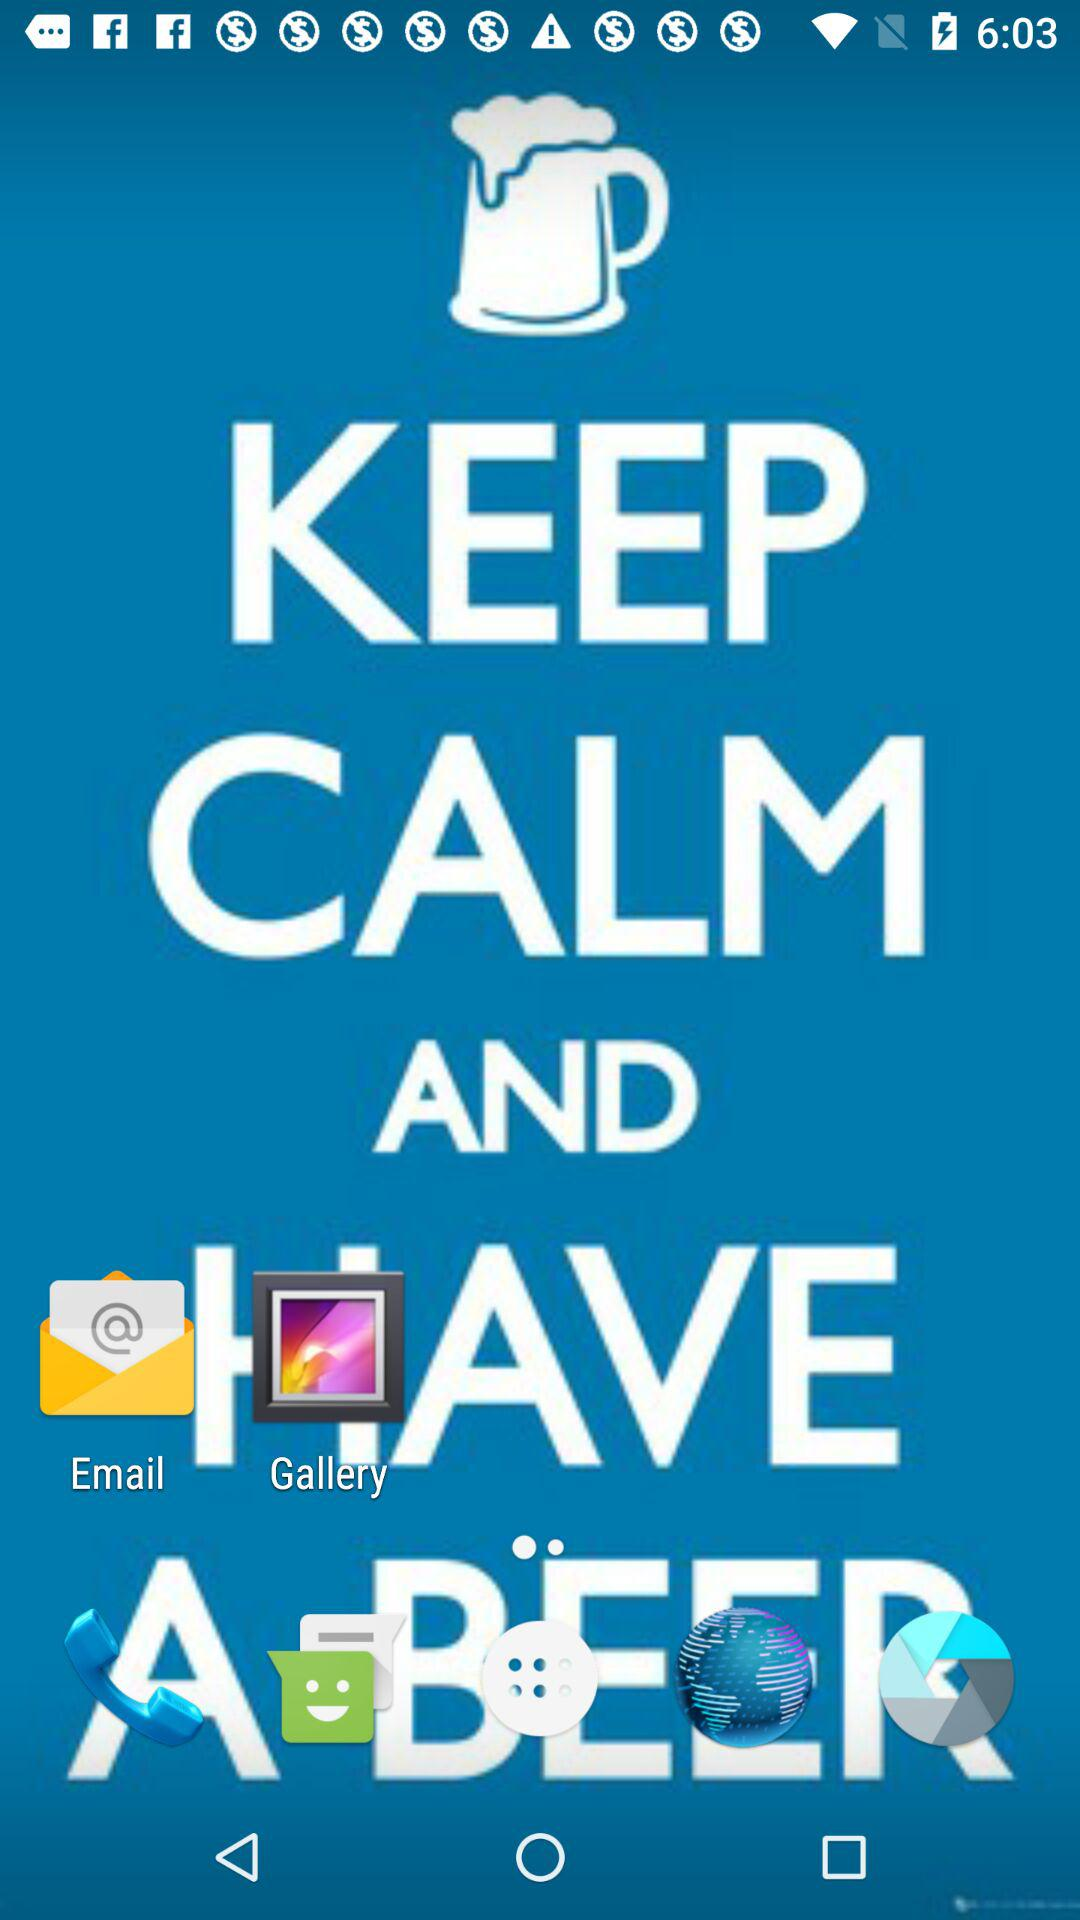How many time units are shown in the screenshot?
Answer the question using a single word or phrase. 2 